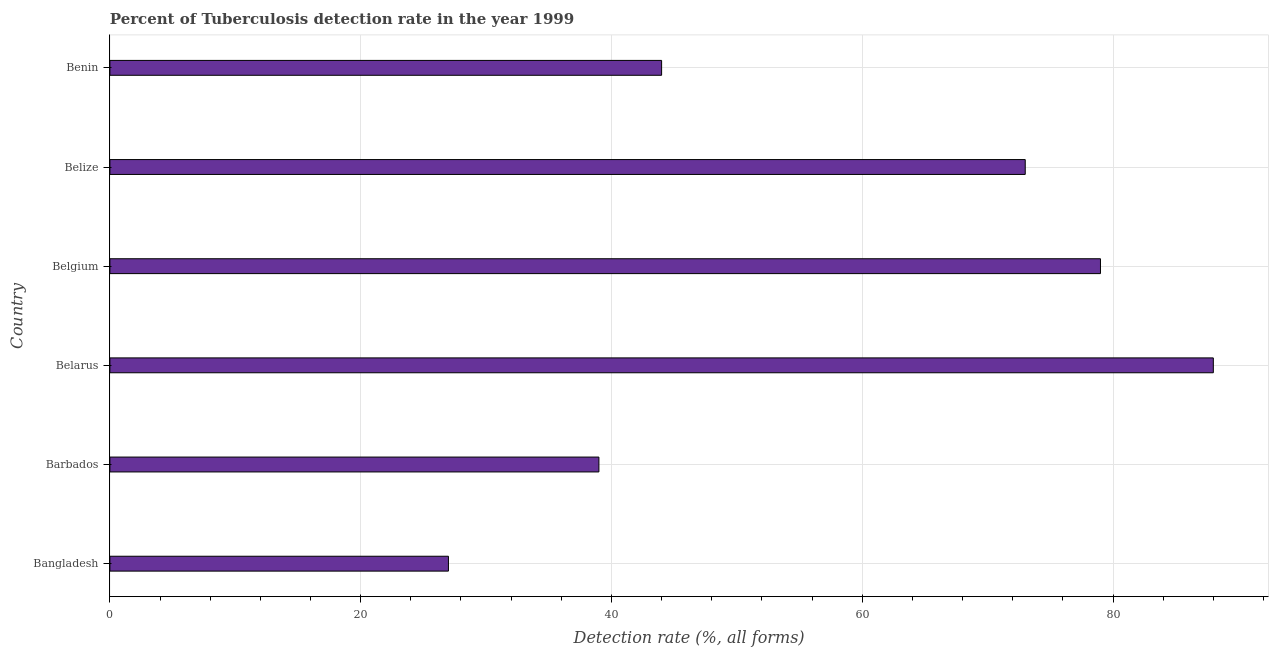What is the title of the graph?
Provide a succinct answer. Percent of Tuberculosis detection rate in the year 1999. What is the label or title of the X-axis?
Give a very brief answer. Detection rate (%, all forms). What is the detection rate of tuberculosis in Belarus?
Offer a very short reply. 88. Across all countries, what is the minimum detection rate of tuberculosis?
Your answer should be compact. 27. In which country was the detection rate of tuberculosis maximum?
Provide a succinct answer. Belarus. What is the sum of the detection rate of tuberculosis?
Ensure brevity in your answer.  350. What is the average detection rate of tuberculosis per country?
Offer a terse response. 58.33. What is the median detection rate of tuberculosis?
Offer a very short reply. 58.5. What is the ratio of the detection rate of tuberculosis in Barbados to that in Belize?
Your response must be concise. 0.53. Is the difference between the detection rate of tuberculosis in Bangladesh and Belgium greater than the difference between any two countries?
Provide a short and direct response. No. Is the sum of the detection rate of tuberculosis in Belgium and Benin greater than the maximum detection rate of tuberculosis across all countries?
Your response must be concise. Yes. What is the difference between the highest and the lowest detection rate of tuberculosis?
Your response must be concise. 61. In how many countries, is the detection rate of tuberculosis greater than the average detection rate of tuberculosis taken over all countries?
Make the answer very short. 3. How many bars are there?
Ensure brevity in your answer.  6. Are all the bars in the graph horizontal?
Give a very brief answer. Yes. How many countries are there in the graph?
Offer a terse response. 6. What is the Detection rate (%, all forms) in Barbados?
Keep it short and to the point. 39. What is the Detection rate (%, all forms) in Belgium?
Provide a succinct answer. 79. What is the Detection rate (%, all forms) in Benin?
Make the answer very short. 44. What is the difference between the Detection rate (%, all forms) in Bangladesh and Barbados?
Offer a very short reply. -12. What is the difference between the Detection rate (%, all forms) in Bangladesh and Belarus?
Provide a short and direct response. -61. What is the difference between the Detection rate (%, all forms) in Bangladesh and Belgium?
Provide a short and direct response. -52. What is the difference between the Detection rate (%, all forms) in Bangladesh and Belize?
Keep it short and to the point. -46. What is the difference between the Detection rate (%, all forms) in Bangladesh and Benin?
Provide a short and direct response. -17. What is the difference between the Detection rate (%, all forms) in Barbados and Belarus?
Your response must be concise. -49. What is the difference between the Detection rate (%, all forms) in Barbados and Belgium?
Your answer should be very brief. -40. What is the difference between the Detection rate (%, all forms) in Barbados and Belize?
Give a very brief answer. -34. What is the difference between the Detection rate (%, all forms) in Barbados and Benin?
Provide a short and direct response. -5. What is the difference between the Detection rate (%, all forms) in Belarus and Belize?
Keep it short and to the point. 15. What is the difference between the Detection rate (%, all forms) in Belgium and Belize?
Make the answer very short. 6. What is the difference between the Detection rate (%, all forms) in Belgium and Benin?
Your answer should be compact. 35. What is the difference between the Detection rate (%, all forms) in Belize and Benin?
Make the answer very short. 29. What is the ratio of the Detection rate (%, all forms) in Bangladesh to that in Barbados?
Ensure brevity in your answer.  0.69. What is the ratio of the Detection rate (%, all forms) in Bangladesh to that in Belarus?
Make the answer very short. 0.31. What is the ratio of the Detection rate (%, all forms) in Bangladesh to that in Belgium?
Offer a very short reply. 0.34. What is the ratio of the Detection rate (%, all forms) in Bangladesh to that in Belize?
Your answer should be compact. 0.37. What is the ratio of the Detection rate (%, all forms) in Bangladesh to that in Benin?
Provide a succinct answer. 0.61. What is the ratio of the Detection rate (%, all forms) in Barbados to that in Belarus?
Offer a terse response. 0.44. What is the ratio of the Detection rate (%, all forms) in Barbados to that in Belgium?
Keep it short and to the point. 0.49. What is the ratio of the Detection rate (%, all forms) in Barbados to that in Belize?
Provide a succinct answer. 0.53. What is the ratio of the Detection rate (%, all forms) in Barbados to that in Benin?
Offer a very short reply. 0.89. What is the ratio of the Detection rate (%, all forms) in Belarus to that in Belgium?
Provide a succinct answer. 1.11. What is the ratio of the Detection rate (%, all forms) in Belarus to that in Belize?
Make the answer very short. 1.21. What is the ratio of the Detection rate (%, all forms) in Belarus to that in Benin?
Give a very brief answer. 2. What is the ratio of the Detection rate (%, all forms) in Belgium to that in Belize?
Ensure brevity in your answer.  1.08. What is the ratio of the Detection rate (%, all forms) in Belgium to that in Benin?
Your answer should be compact. 1.79. What is the ratio of the Detection rate (%, all forms) in Belize to that in Benin?
Offer a very short reply. 1.66. 